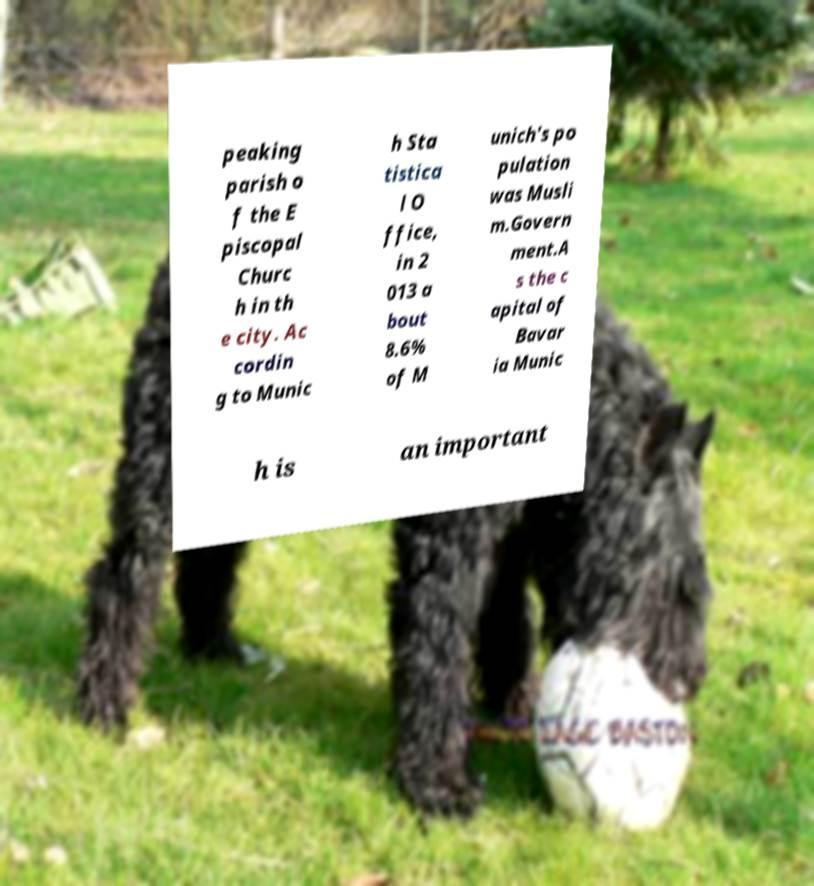What messages or text are displayed in this image? I need them in a readable, typed format. peaking parish o f the E piscopal Churc h in th e city. Ac cordin g to Munic h Sta tistica l O ffice, in 2 013 a bout 8.6% of M unich's po pulation was Musli m.Govern ment.A s the c apital of Bavar ia Munic h is an important 